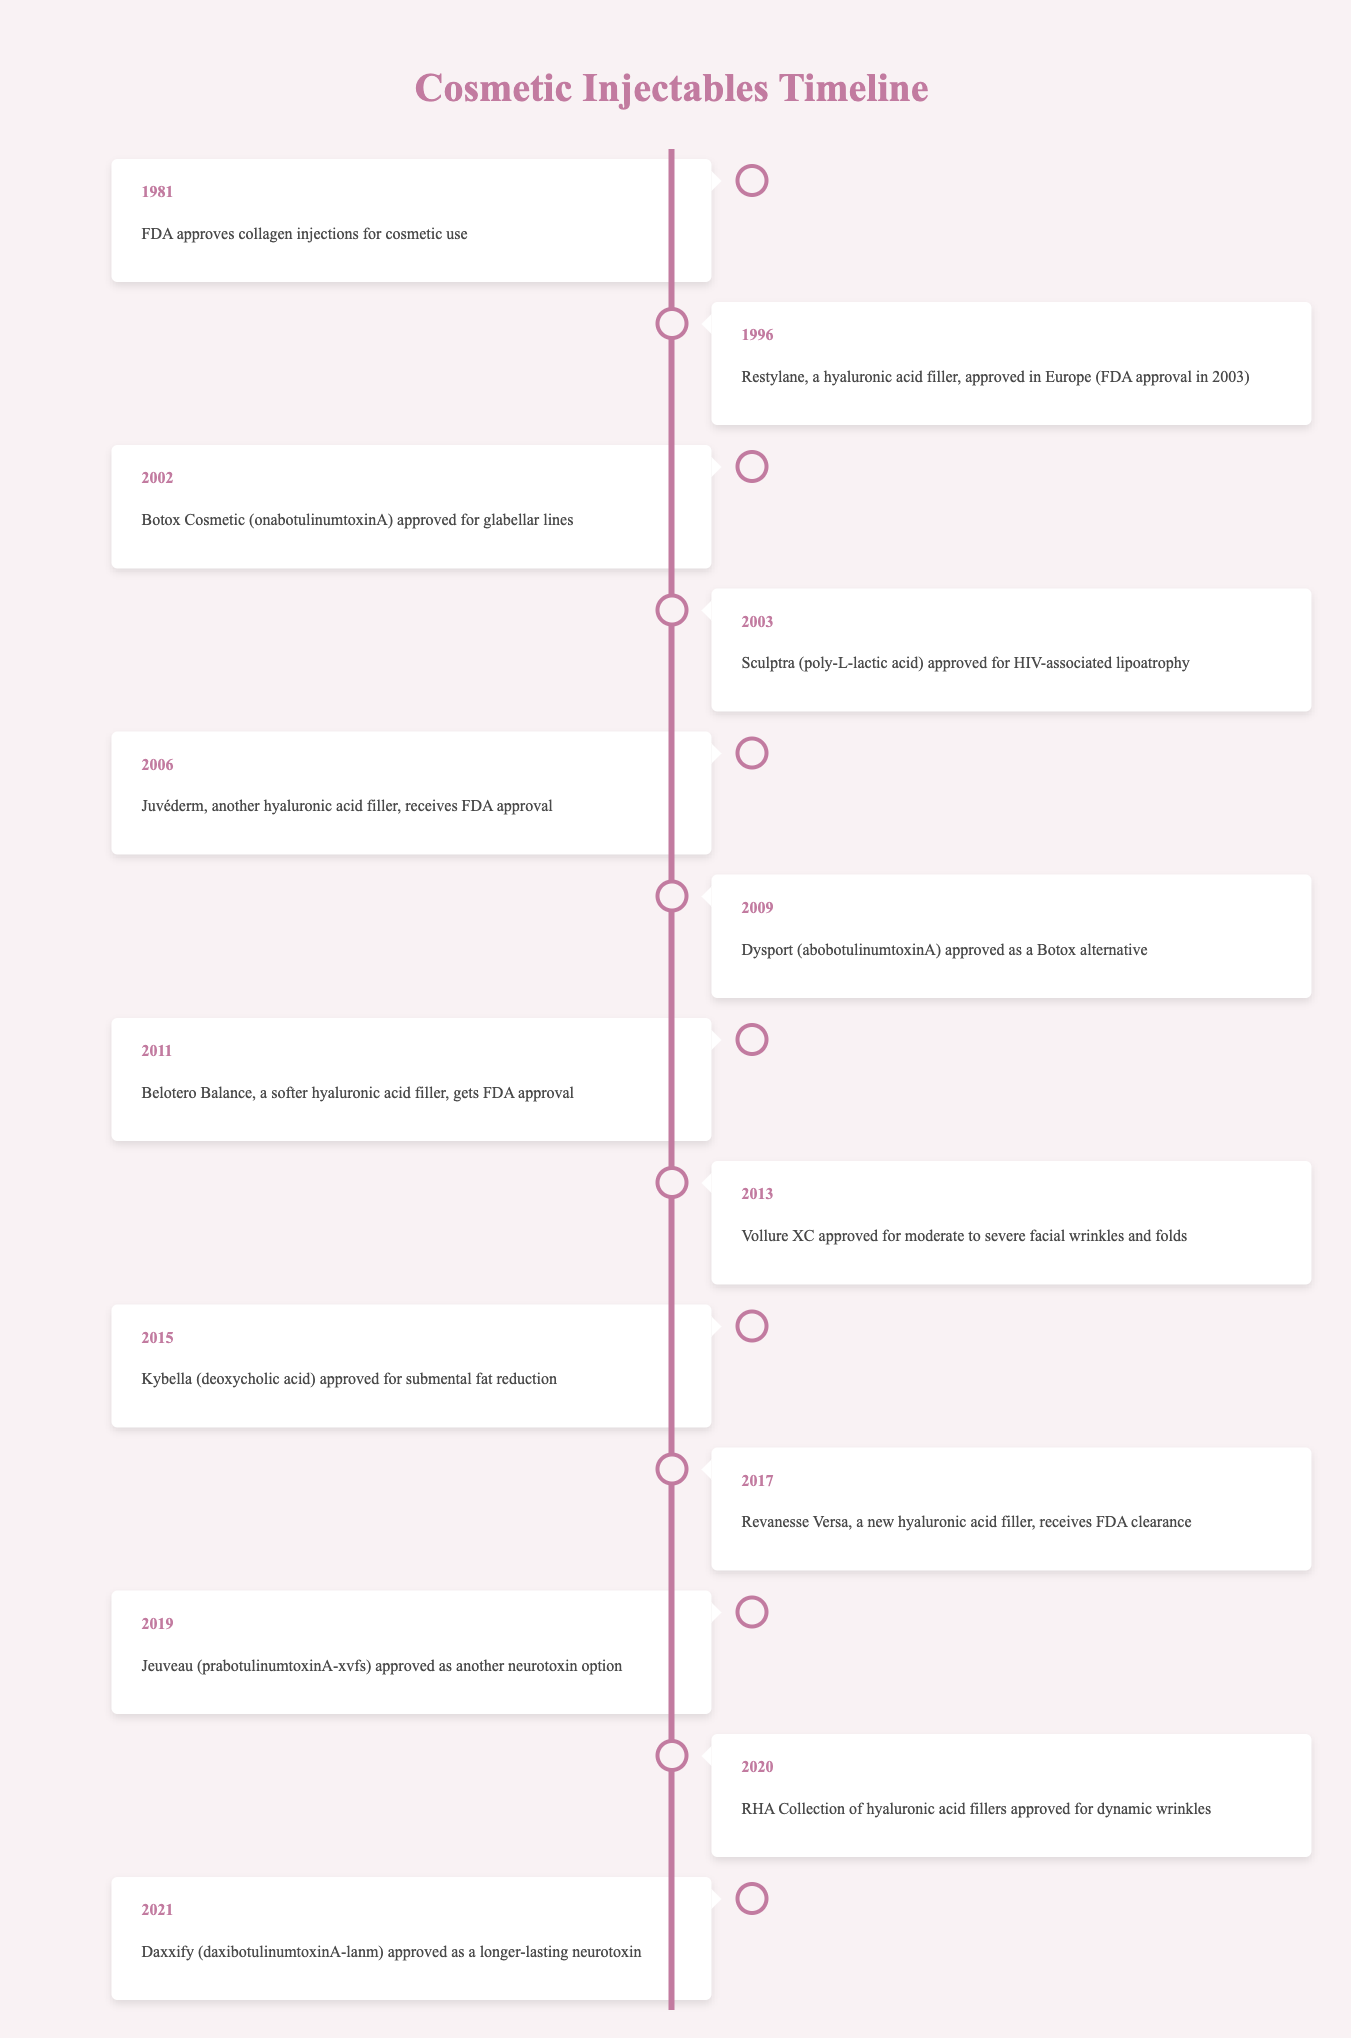What year did the FDA approve collagen injections for cosmetic use? According to the timeline, collagen injections were approved in 1981.
Answer: 1981 Which injectable was approved for glabellar lines in 2002? The timeline indicates that Botox Cosmetic (onabotulinumtoxinA) was approved for glabellar lines in 2002.
Answer: Botox Cosmetic How many years passed between the approval of Sculptra and Juvéderm? Sculptra was approved in 2003 and Juvéderm in 2006. The difference between 2006 and 2003 is 3 years.
Answer: 3 years Was Restylane approved by the FDA in 1996? The timeline specifies that Restylane was approved in Europe in 1996 but states it received FDA approval in 2003, making the statement false.
Answer: No How many hyaluronic acid fillers received FDA approval before 2015? Based on the timeline, the fillers before 2015 include Restylane (approved in 2003), Juvéderm (2006), Belotero Balance (2011), and Vollure XC (2013). Thus, there are 4 hyaluronic acid fillers approved before 2015.
Answer: 4 Which injectable received FDA approval last from this timeline? According to the timeline, Daxxify (daxibotulinumtoxinA-lanm) was the last injectable approved in 2021.
Answer: Daxxify What is the earliest year mentioned in the timeline for cosmetic injectables? The earliest year stated in the timeline is 1981, which is when collagen injections were approved for cosmetic use.
Answer: 1981 How many years are between the approval of Kybella and Revanesse Versa? Kybella was approved in 2015, and Revanesse Versa was approved in 2017. The difference is 2 years.
Answer: 2 years In what year did the FDA approve RHA Collection of hyaluronic acid fillers? The RHA Collection of hyaluronic acid fillers was approved in 2020, as noted in the timeline.
Answer: 2020 